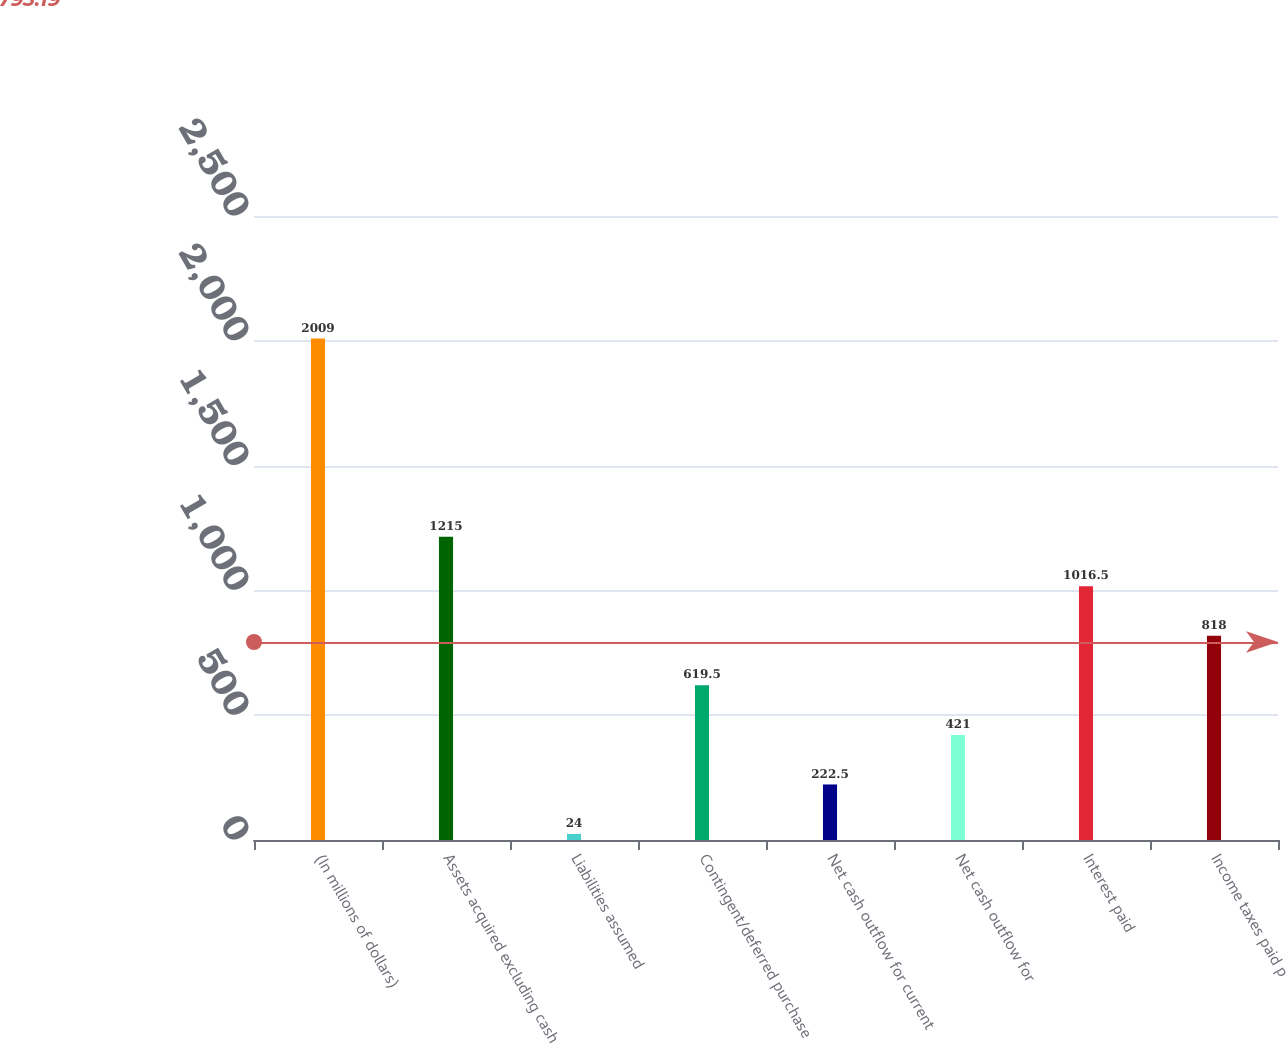Convert chart to OTSL. <chart><loc_0><loc_0><loc_500><loc_500><bar_chart><fcel>(In millions of dollars)<fcel>Assets acquired excluding cash<fcel>Liabilities assumed<fcel>Contingent/deferred purchase<fcel>Net cash outflow for current<fcel>Net cash outflow for<fcel>Interest paid<fcel>Income taxes paid p<nl><fcel>2009<fcel>1215<fcel>24<fcel>619.5<fcel>222.5<fcel>421<fcel>1016.5<fcel>818<nl></chart> 